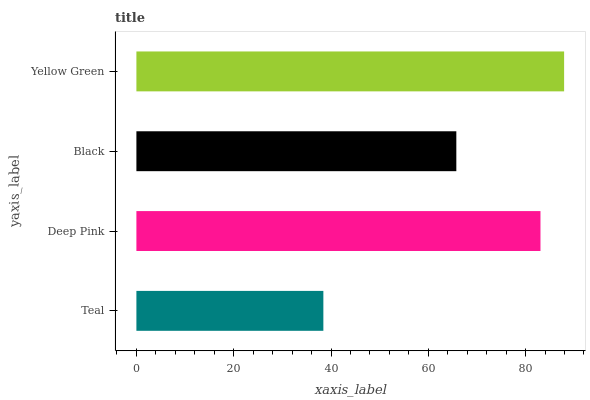Is Teal the minimum?
Answer yes or no. Yes. Is Yellow Green the maximum?
Answer yes or no. Yes. Is Deep Pink the minimum?
Answer yes or no. No. Is Deep Pink the maximum?
Answer yes or no. No. Is Deep Pink greater than Teal?
Answer yes or no. Yes. Is Teal less than Deep Pink?
Answer yes or no. Yes. Is Teal greater than Deep Pink?
Answer yes or no. No. Is Deep Pink less than Teal?
Answer yes or no. No. Is Deep Pink the high median?
Answer yes or no. Yes. Is Black the low median?
Answer yes or no. Yes. Is Yellow Green the high median?
Answer yes or no. No. Is Teal the low median?
Answer yes or no. No. 